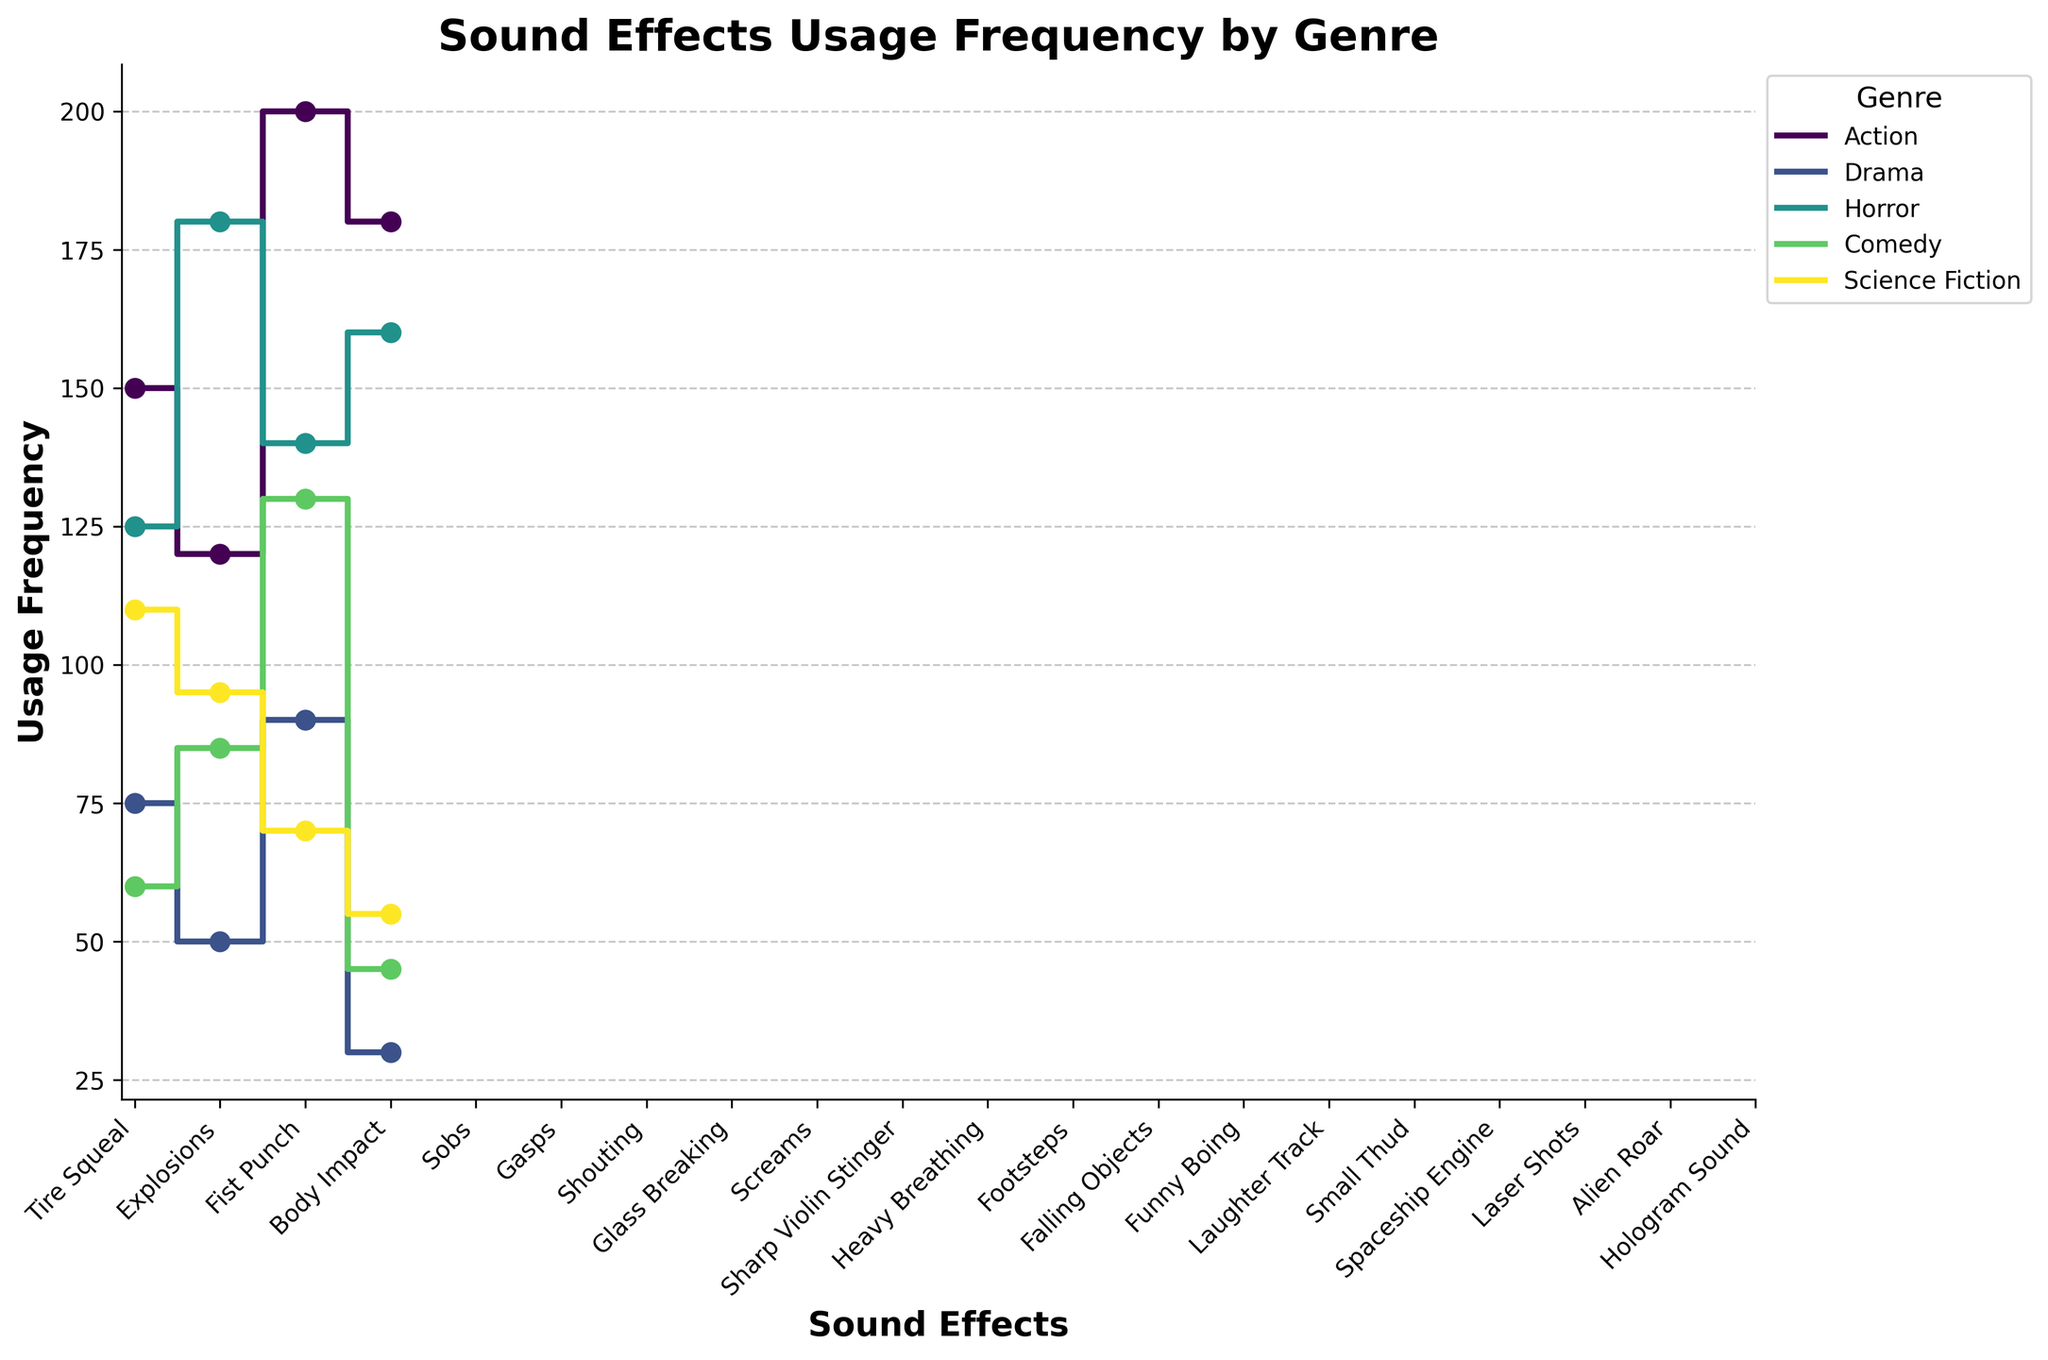What is the title of the plot? The title of a plot is typically placed at the top of the figure. In this case, the title is set to "Sound Effects Usage Frequency by Genre" as indicated in the code.
Answer: Sound Effects Usage Frequency by Genre Which genre has the highest usage frequency for the "Heavy Breathing" sound effect? The "Heavy Breathing" sound effect is found in the Horror genre under the "Chase" scene type, with a usage frequency of 140 as indicated in the data.
Answer: Horror What are the x and y labels of the plot? The x label and y label are specified in the code. The x label is "Sound Effects," and the y label is "Usage Frequency" and they are positioned along their respective axes.
Answer: Sound Effects, Usage Frequency How does the usage frequency of "Explosions" in Action compare to "Shouting" in Drama? By looking at the step plot, "Explosions" in Action has a usage frequency of 120, and "Shouting" in Drama has 90. Therefore, "Explosions" are used more frequently than "Shouting."
Answer: Explosions are used more frequently Which genre has the most consistent usage across different sound effects, and how can you tell? Comparing the lines on the plot, the Drama genre has the most consistent usage across different sound effects as its step lines are more horizontal and closely packed, showing less variation in frequencies.
Answer: Drama What is the highest usage frequency of any sound effect in the plot, and which genre does it belong to? The highest usage frequency can be identified by finding the highest data point on the plot. "Fist Punch" in the Action genre has the highest usage frequency of 200.
Answer: 200, Action For the Horror genre, what is the difference in usage frequency between "Screams" and "Sharp Violin Stinger"? For the Horror genre, "Screams" have a frequency of 125 and "Sharp Violin Stinger" has 180. The difference is calculated by subtracting the smaller frequency from the larger one, i.e., 180 - 125 = 55.
Answer: 55 What is the total usage frequency of sound effects in the Science Fiction genre? By summing the frequencies of all sound effects in Science Fiction, we get: Spaceship Engine (110) + Laser Shots (95) + Alien Roar (70) + Hologram Sound (55). So, 110 + 95 + 70 + 55 = 330.
Answer: 330 Which scene type in the Comedy genre shows higher usage frequency of sound effects: Slapstick or Situational Comedy? By comparing the usage frequencies in Comedy genre: Slapstick ("Falling Objects" 60, "Funny Boing" 85) = 60 + 85 = 145 vs Situational Comedy ("Laughter Track" 130, "Small Thud" 45) = 130 + 45 = 175. Situational Comedy has a higher total usage.
Answer: Situational Comedy 